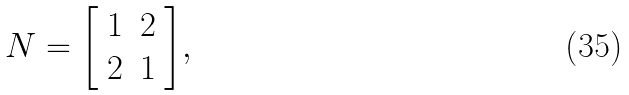<formula> <loc_0><loc_0><loc_500><loc_500>N = { \left [ \begin{array} { l l } { 1 } & { 2 } \\ { 2 } & { 1 } \end{array} \right ] } ,</formula> 